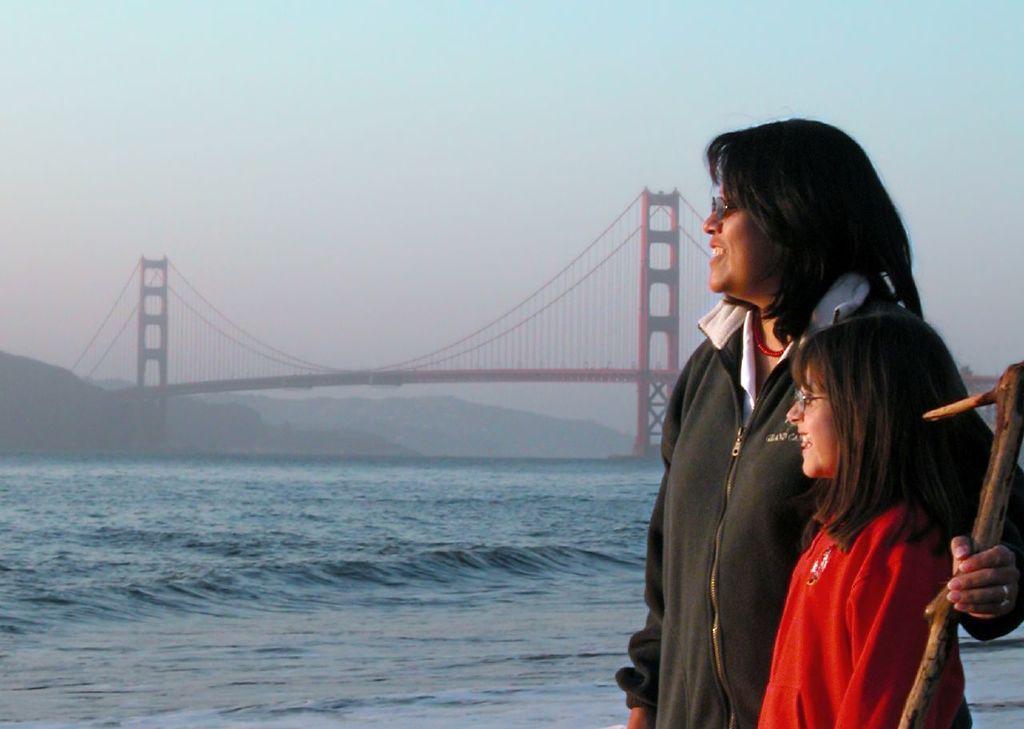Can you describe this image briefly? This image consists of two persons. The girl is wearing a red jacket. The woman is wearing a black jacket. At the bottom, there is water. In the background, we can see a bridge along with the strings. At the top, there is sky. On the left, we can see mountains. 